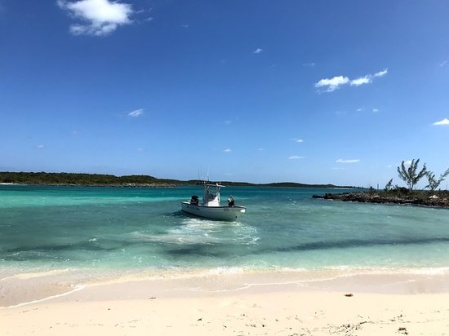Can you tell me more about the type of boat we see here? The boat in the image appears to be a small motorboat, commonly used for recreational activities such as fishing or short coastal trips. Its compact size and design make it ideal for navigating shallow waters and nearshore areas. The boat’s white and blue colors add to its aesthetic appeal, harmoniously blending with the surrounding oceanic hues. What potential activities might people on this boat be engaged in? People on this boat could be engaged in various recreational activities. They might be fishing, enjoying a leisurely cruise, or heading to a nearby island for exploration. The serene and calm waters suggest an ideal environment for outdoor activities like swimming, snorkeling, or simply basking in the sun. The clear weather and tranquil surroundings enhance the overall experience, making it a perfect day for some waterside fun. 